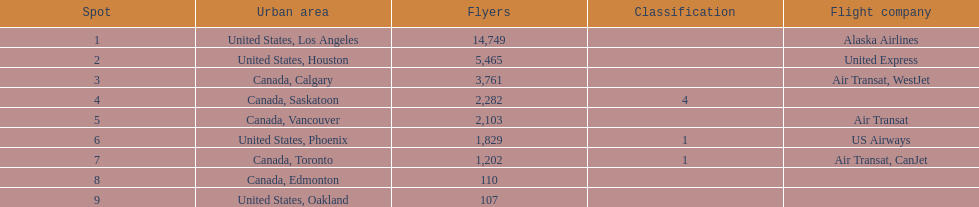Which airline carries the most passengers? Alaska Airlines. 